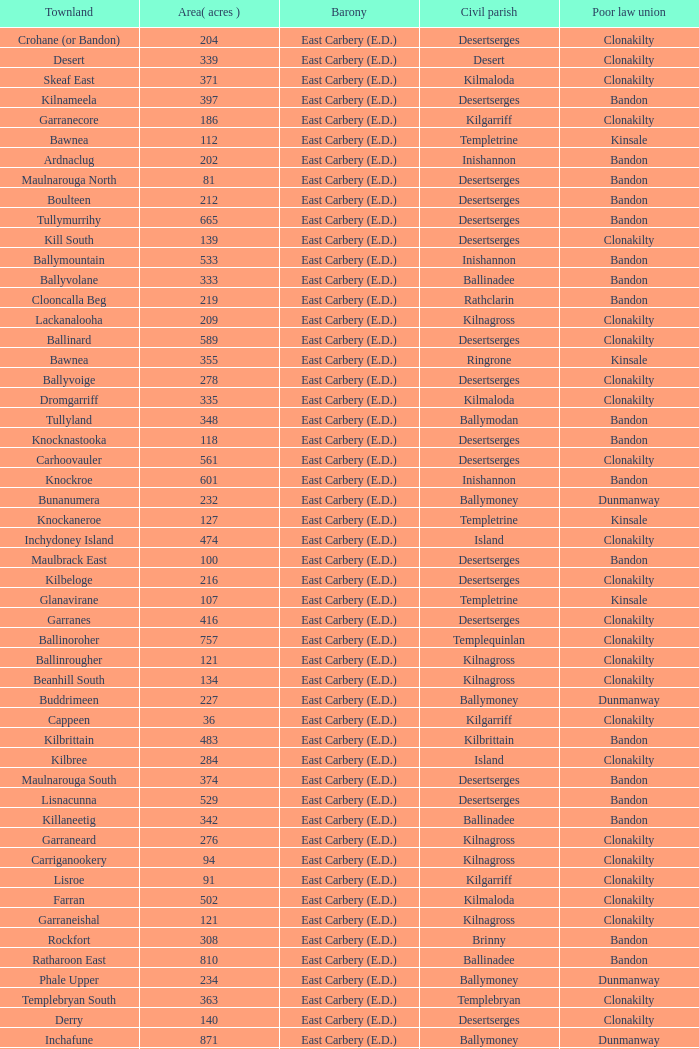What is the poor law union of the Ardacrow townland? Bandon. 